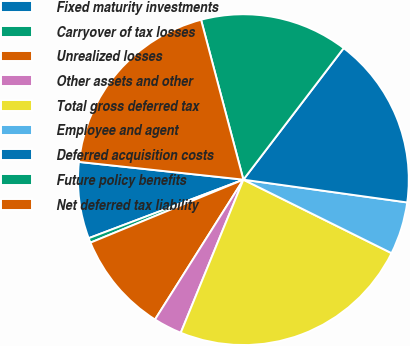Convert chart to OTSL. <chart><loc_0><loc_0><loc_500><loc_500><pie_chart><fcel>Fixed maturity investments<fcel>Carryover of tax losses<fcel>Unrealized losses<fcel>Other assets and other<fcel>Total gross deferred tax<fcel>Employee and agent<fcel>Deferred acquisition costs<fcel>Future policy benefits<fcel>Net deferred tax liability<nl><fcel>7.47%<fcel>0.46%<fcel>9.81%<fcel>2.79%<fcel>23.85%<fcel>5.13%<fcel>16.83%<fcel>14.49%<fcel>19.17%<nl></chart> 